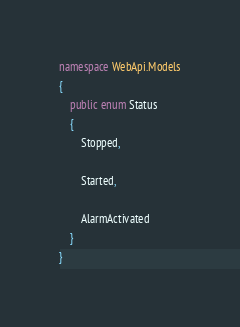<code> <loc_0><loc_0><loc_500><loc_500><_C#_>namespace WebApi.Models
{
    public enum Status
    {
        Stopped,

        Started,

        AlarmActivated
    }
}
</code> 